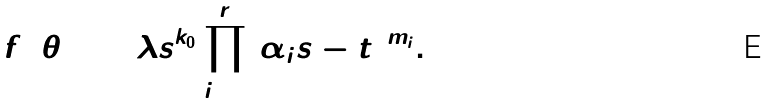<formula> <loc_0><loc_0><loc_500><loc_500>f _ { 4 } ( \theta _ { 2 } ) = \lambda s ^ { k _ { 0 } } \prod _ { i = 0 } ^ { r } ( \alpha _ { i } s - t ) ^ { m _ { i } } .</formula> 